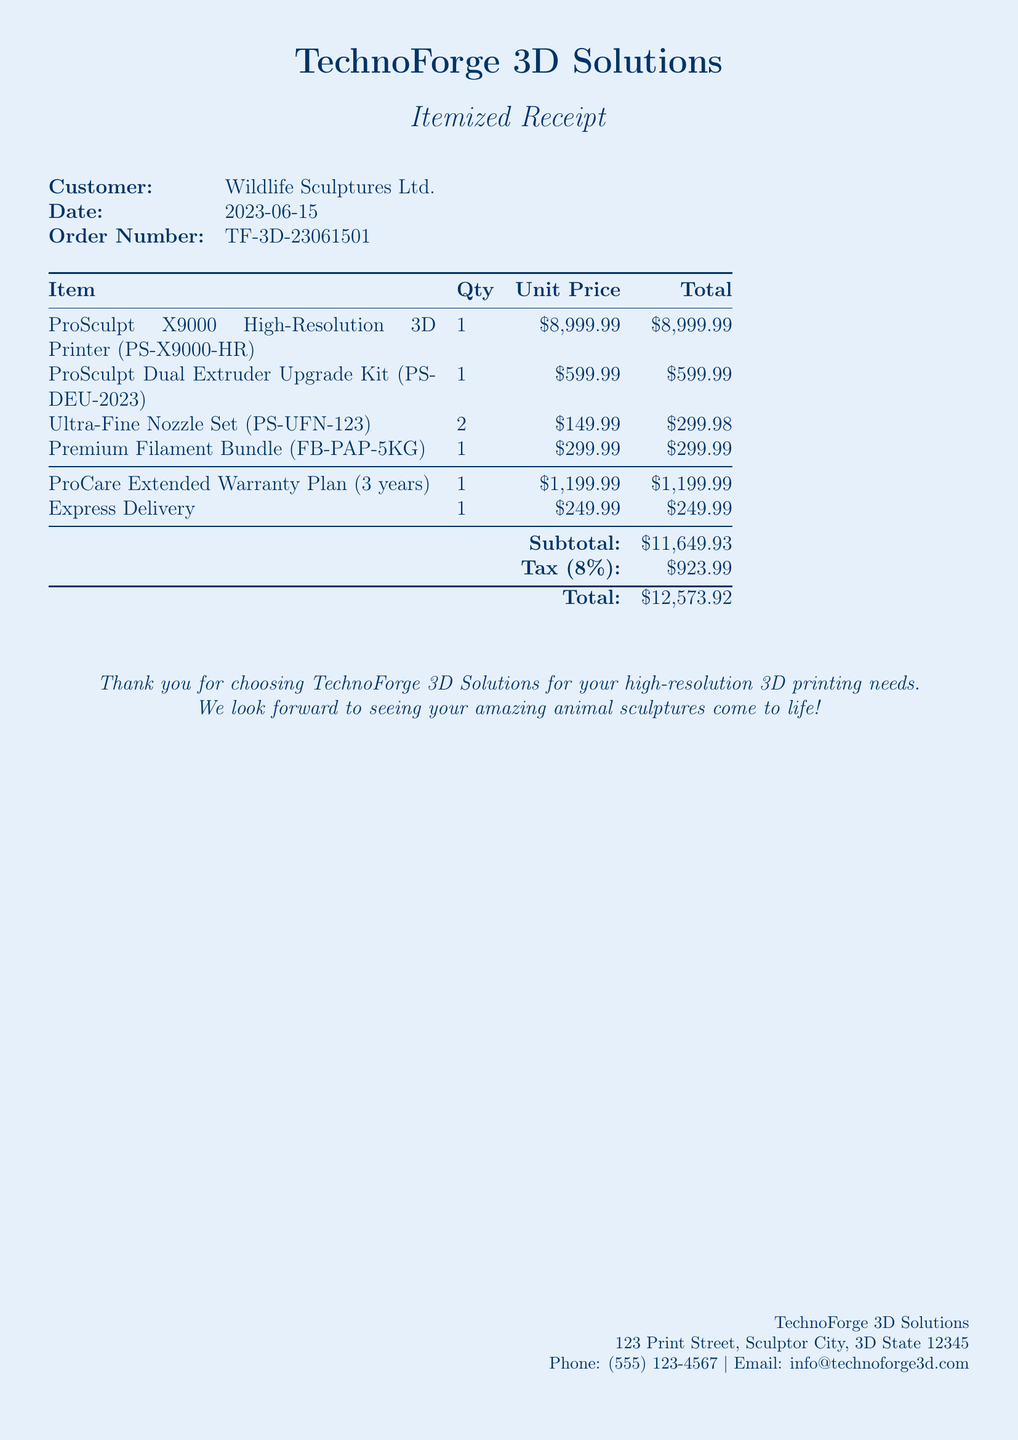what is the total amount due? The total is listed as the final amount after tax and is highlighted at the bottom of the receipt.
Answer: $12,573.92 who is the customer? The customer’s name is mentioned at the top of the receipt under the customer information section.
Answer: Wildlife Sculptures Ltd what is the date of the purchase? The date is specified below the customer name along with the order number.
Answer: 2023-06-15 how many Ultra-Fine Nozzle Sets were purchased? The quantity of Ultra-Fine Nozzle Sets can be found in the itemized list of purchased items.
Answer: 2 what is the price of the ProCare Extended Warranty Plan? The price is provided in the itemized list alongside the description of the warranty plan.
Answer: $1,199.99 what is the subtotal before tax? The subtotal is listed immediately before the tax amount in the itemized receipt section.
Answer: $11,649.93 how much was paid for Express Delivery? The charge for Express Delivery is clearly listed as a separate item in the receipt.
Answer: $249.99 what is the tax rate applied to the purchase? The tax amount is given on the receipt along with the subtotal, allowing for calculation of the rate as displayed.
Answer: 8% how many items were included in the order? The total number of individual items can be calculated by counting each line in the item list.
Answer: 6 